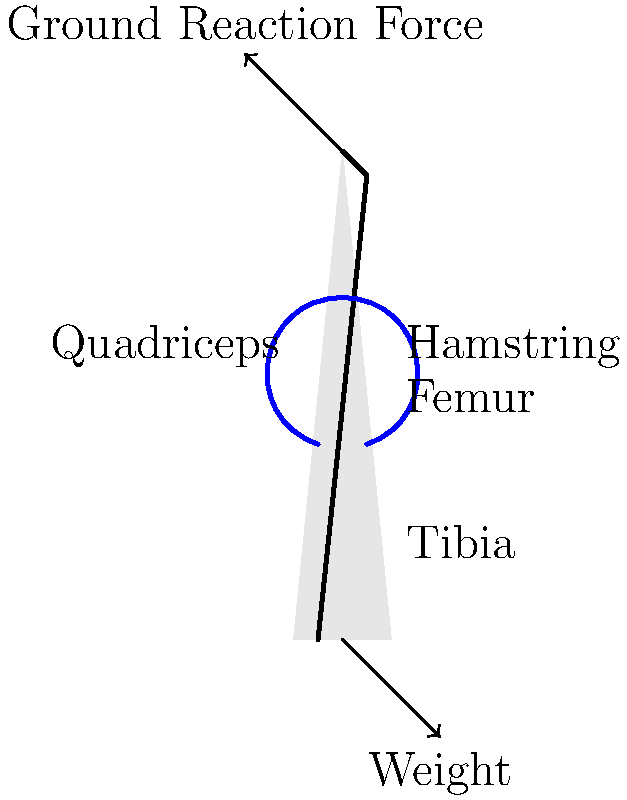As the director of the city museum, you're planning an interactive exhibit on human biomechanics. Which muscle group is primarily responsible for extending the knee joint during the stance phase of walking, and how does this action contribute to the forward propulsion of the body? To answer this question, let's break down the biomechanics of walking:

1. The stance phase is the period when the foot is in contact with the ground.

2. During this phase, the leg needs to support the body weight and propel it forward.

3. The knee joint plays a crucial role in this process:
   a. At the beginning of the stance phase, the knee is slightly flexed.
   b. As the body moves forward over the supporting leg, the knee needs to extend.

4. The quadriceps muscle group, located on the front of the thigh, is primarily responsible for extending the knee joint:
   a. It consists of four muscles: rectus femoris, vastus lateralis, vastus medialis, and vastus intermedius.
   b. These muscles attach to the patella (kneecap) via the patellar tendon.

5. When the quadriceps contract, they pull on the patella, which in turn pulls on the tibia, causing the knee to extend.

6. This knee extension contributes to forward propulsion in several ways:
   a. It pushes the body upward and forward, counteracting the downward force of gravity.
   b. It helps to straighten the leg, creating a rigid lever that can push against the ground.
   c. The extension of the knee, combined with the push-off from the ankle, generates the force necessary to propel the body forward.

7. The action of the quadriceps works in conjunction with other muscle groups, such as the hip extensors and ankle plantar flexors, to create a smooth, efficient walking gait.

Understanding this biomechanical process is crucial for creating an engaging and educational exhibit that demonstrates how the human body achieves locomotion.
Answer: Quadriceps; extends knee, creating rigid lever for forward propulsion 